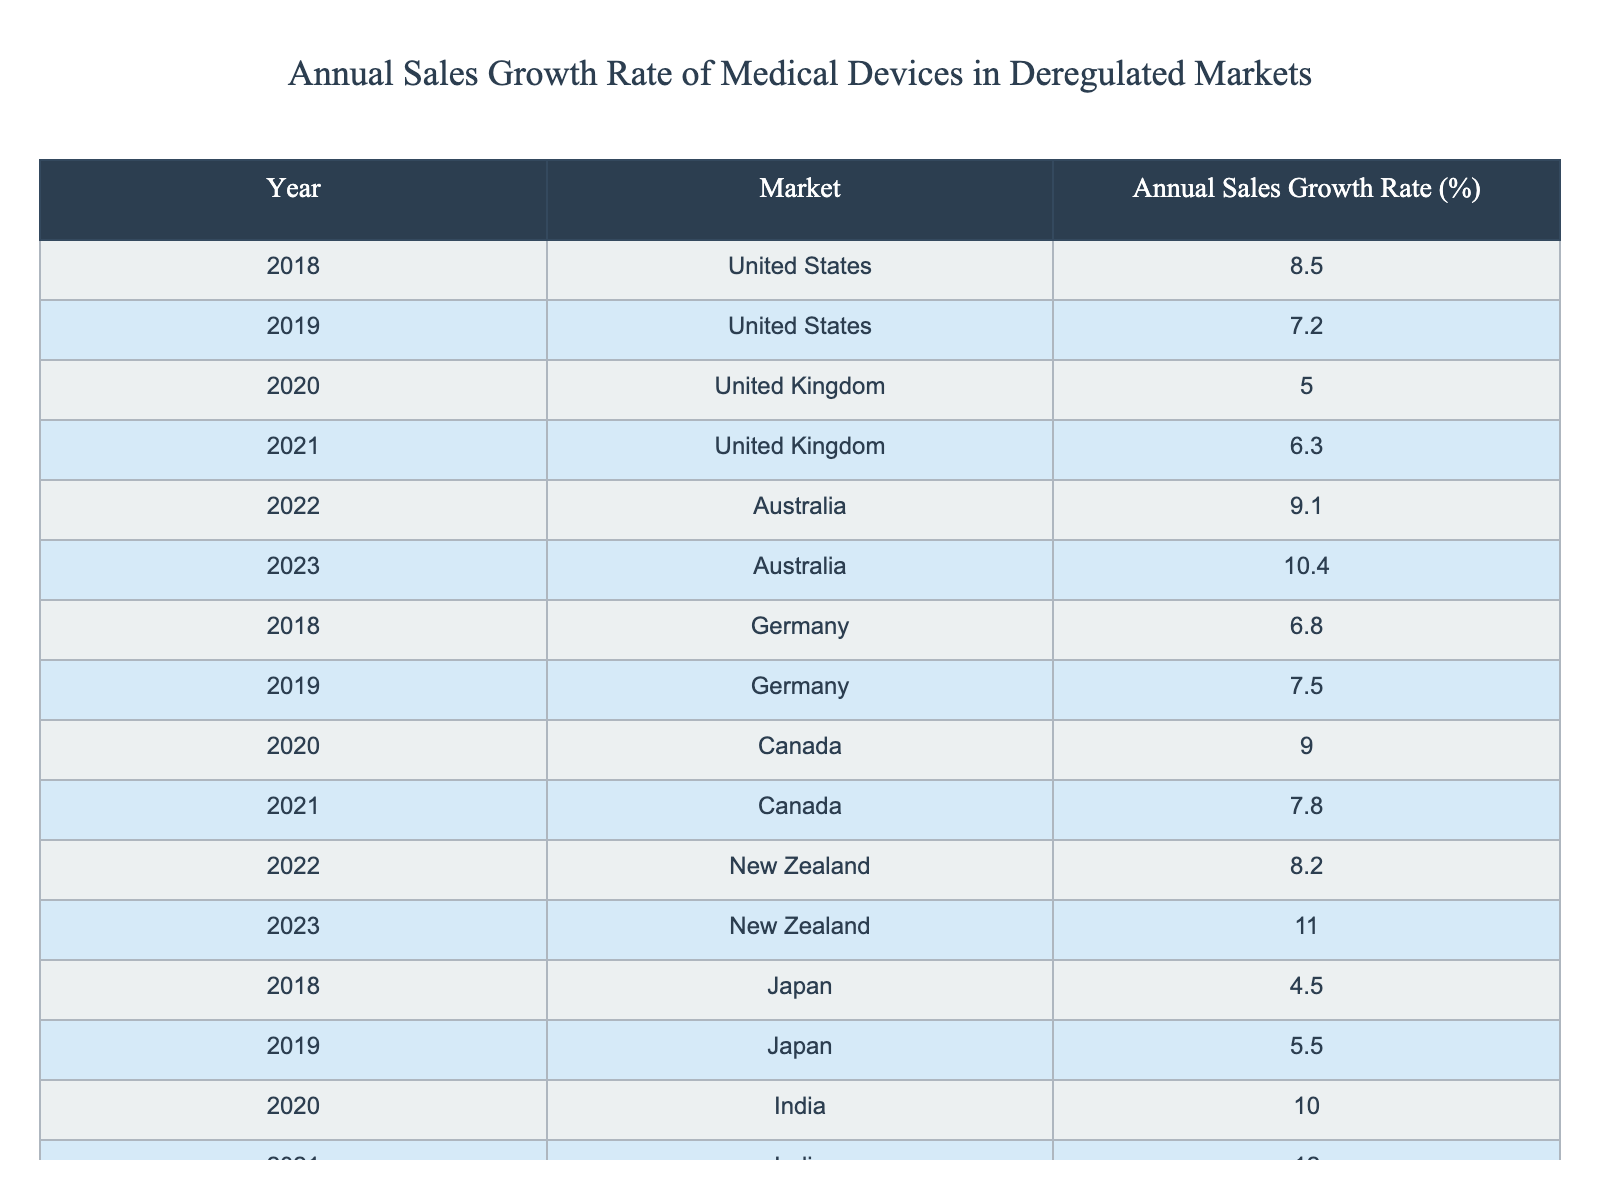What was the Annual Sales Growth Rate for the United States in 2018? The table shows that the Annual Sales Growth Rate for the United States in 2018 is listed directly under that year. It states 8.5%.
Answer: 8.5% Which market had the highest Annual Sales Growth Rate in 2023? By looking at the 2023 row for all markets listed, Australia has the highest Annual Sales Growth Rate at 10.4%.
Answer: Australia What is the difference between the Annual Sales Growth Rate in Canada in 2020 and 2021? In 2020, Canada had an Annual Sales Growth Rate of 9.0%, and in 2021 it was 7.8%. The difference is 9.0% - 7.8% = 1.2%.
Answer: 1.2% Is the Annual Sales Growth Rate for South Korea in 2022 higher than that of Japan in 2019? South Korea's rate in 2022 is 8.0%, while Japan's rate in 2019 is 5.5%. Since 8.0% is greater than 5.5%, the statement is true.
Answer: Yes What was the average Annual Sales Growth Rate for the United Kingdom for the years 2020 and 2021? The Annual Sales Growth Rate for the United Kingdom was 5.0% in 2020 and 6.3% in 2021. The average is (5.0% + 6.3%) / 2 = 5.65%.
Answer: 5.65% Which market showed consistent growth every year from 2018 to 2023? By examining each row for the values and comparing each year's rate, India shows consistent growth, increasing from 10.0% in 2020 to 12.0% in 2021.
Answer: No What is the total Annual Sales Growth Rate for Australia from 2018 through 2023? For Australia, the Annual Sales Growth Rates are 9.1% in 2022 and 10.4% in 2023. Adding these together gives 9.1% + 10.4% = 19.5%.
Answer: 19.5% Did Germany experience an increase in the Annual Sales Growth Rate from 2018 to 2019? In 2018, Germany's rate was 6.8%, and in 2019 it increased to 7.5%, indicating an increase.
Answer: Yes What was the maximum Annual Sales Growth Rate recorded in the table? By scanning through all the rates listed, the maximum value is 12.0% from India in 2021.
Answer: 12.0% 